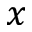Convert formula to latex. <formula><loc_0><loc_0><loc_500><loc_500>x</formula> 